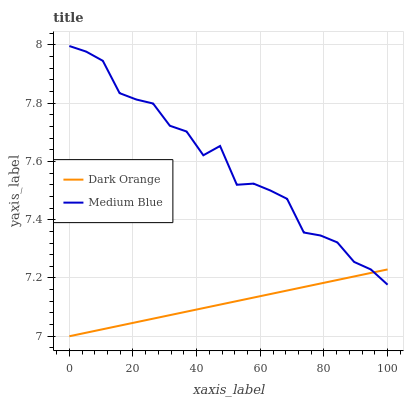Does Medium Blue have the minimum area under the curve?
Answer yes or no. No. Is Medium Blue the smoothest?
Answer yes or no. No. Does Medium Blue have the lowest value?
Answer yes or no. No. 